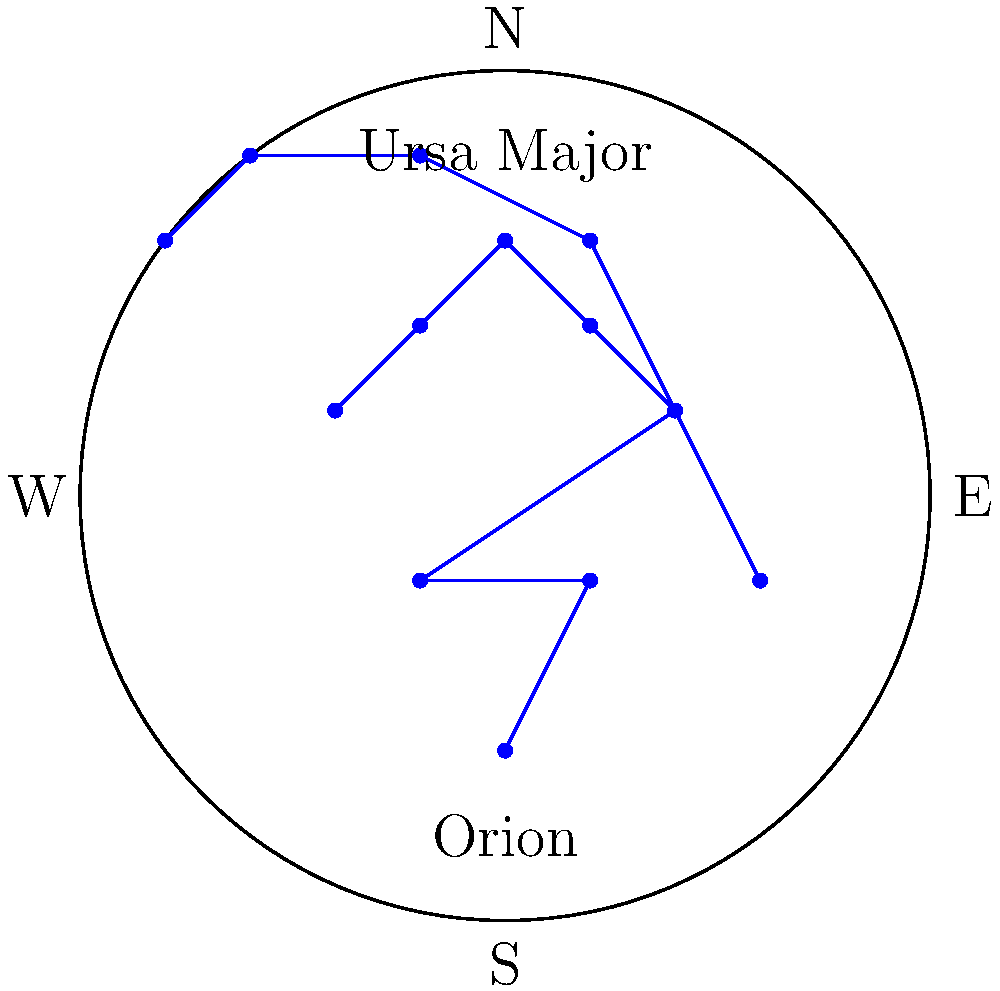As a personal trainer who occasionally helps with class instruction, you want to incorporate some astronomy knowledge into an outdoor night workout. Which of the constellations shown in the diagram is typically visible during summer evenings in the Northern Hemisphere, and how can you use this information to engage your fitness class? To answer this question, let's break it down step-by-step:

1. The diagram shows two constellations: Orion and Ursa Major.

2. Orion is a winter constellation in the Northern Hemisphere. It's typically visible from November to February.

3. Ursa Major, also known as the Great Bear or the Big Dipper, is visible year-round in the Northern Hemisphere but is most prominent in the spring.

4. During summer evenings in the Northern Hemisphere, Ursa Major is still visible high in the sky, while Orion is not visible as it's below the horizon.

5. As a personal trainer, you can use this information to engage your fitness class by:
   a) Pointing out Ursa Major during outdoor evening workouts.
   b) Using the constellation as a reference point for exercises (e.g., "Stretch your arms towards the Big Dipper").
   c) Incorporating constellation-themed exercises or circuit training stations.
   d) Using the visibility of Ursa Major as a way to discuss seasonal changes and how they affect outdoor workout schedules.

Therefore, Ursa Major is the constellation typically visible during summer evenings in the Northern Hemisphere, and it can be used to add an educational and engaging element to your fitness classes.
Answer: Ursa Major 